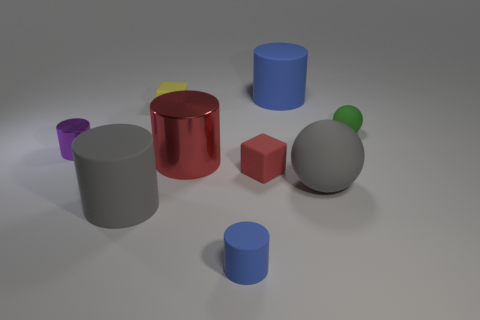The rubber cylinder that is the same color as the big sphere is what size?
Offer a terse response. Large. There is a big object that is on the left side of the red matte thing and behind the red cube; what is its shape?
Your response must be concise. Cylinder. What is the material of the tiny cube that is the same color as the large metal cylinder?
Offer a very short reply. Rubber. The small matte cylinder has what color?
Your response must be concise. Blue. What is the color of the cube that is behind the rubber block that is in front of the purple object?
Ensure brevity in your answer.  Yellow. Is there a yellow object that has the same material as the large red cylinder?
Make the answer very short. No. What is the material of the blue thing that is on the left side of the matte cylinder behind the large gray matte cylinder?
Keep it short and to the point. Rubber. What number of other small red things are the same shape as the small red thing?
Give a very brief answer. 0. The tiny yellow thing is what shape?
Offer a terse response. Cube. Is the number of large red cylinders less than the number of shiny things?
Offer a terse response. Yes. 